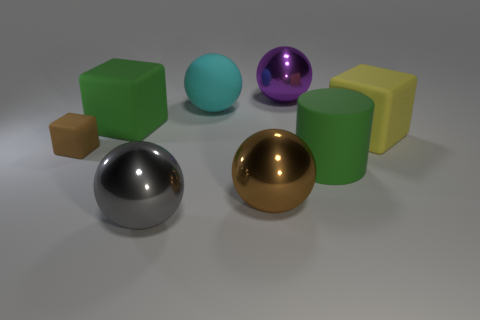Subtract all big green matte cubes. How many cubes are left? 2 Add 1 rubber objects. How many objects exist? 9 Subtract all gray spheres. How many spheres are left? 3 Subtract all large rubber blocks. Subtract all matte cubes. How many objects are left? 3 Add 1 big cyan balls. How many big cyan balls are left? 2 Add 5 large gray metal things. How many large gray metal things exist? 6 Subtract 1 brown cubes. How many objects are left? 7 Subtract all cubes. How many objects are left? 5 Subtract 3 blocks. How many blocks are left? 0 Subtract all purple spheres. Subtract all gray blocks. How many spheres are left? 3 